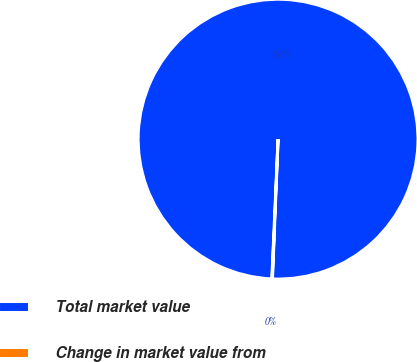Convert chart. <chart><loc_0><loc_0><loc_500><loc_500><pie_chart><fcel>Total market value<fcel>Change in market value from<nl><fcel>99.93%<fcel>0.07%<nl></chart> 